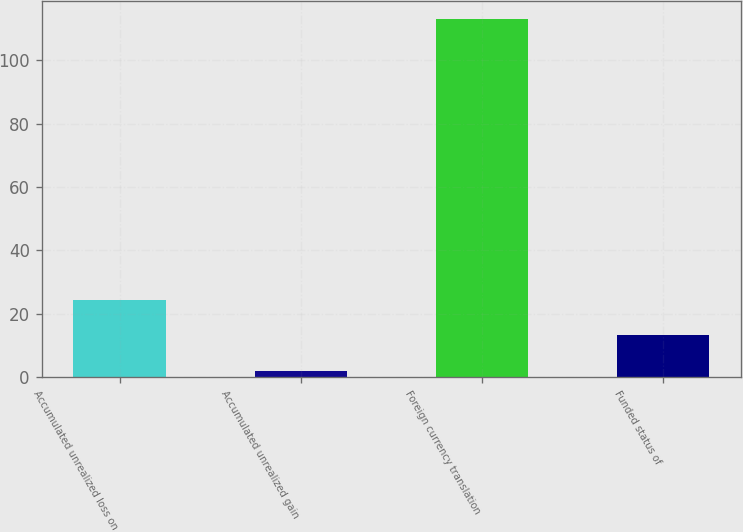<chart> <loc_0><loc_0><loc_500><loc_500><bar_chart><fcel>Accumulated unrealized loss on<fcel>Accumulated unrealized gain<fcel>Foreign currency translation<fcel>Funded status of<nl><fcel>24.2<fcel>2<fcel>113<fcel>13.1<nl></chart> 